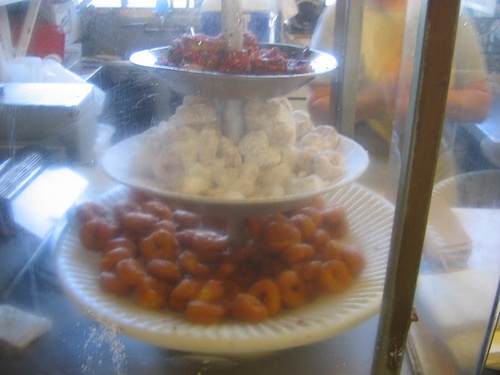Describe the objects in this image and their specific colors. I can see donut in lavender, darkgray, maroon, tan, and gray tones, people in lavender, darkgray, gray, tan, and maroon tones, donut in lavender, brown, and maroon tones, donut in lavender, maroon, and brown tones, and donut in lavender, brown, maroon, and gray tones in this image. 